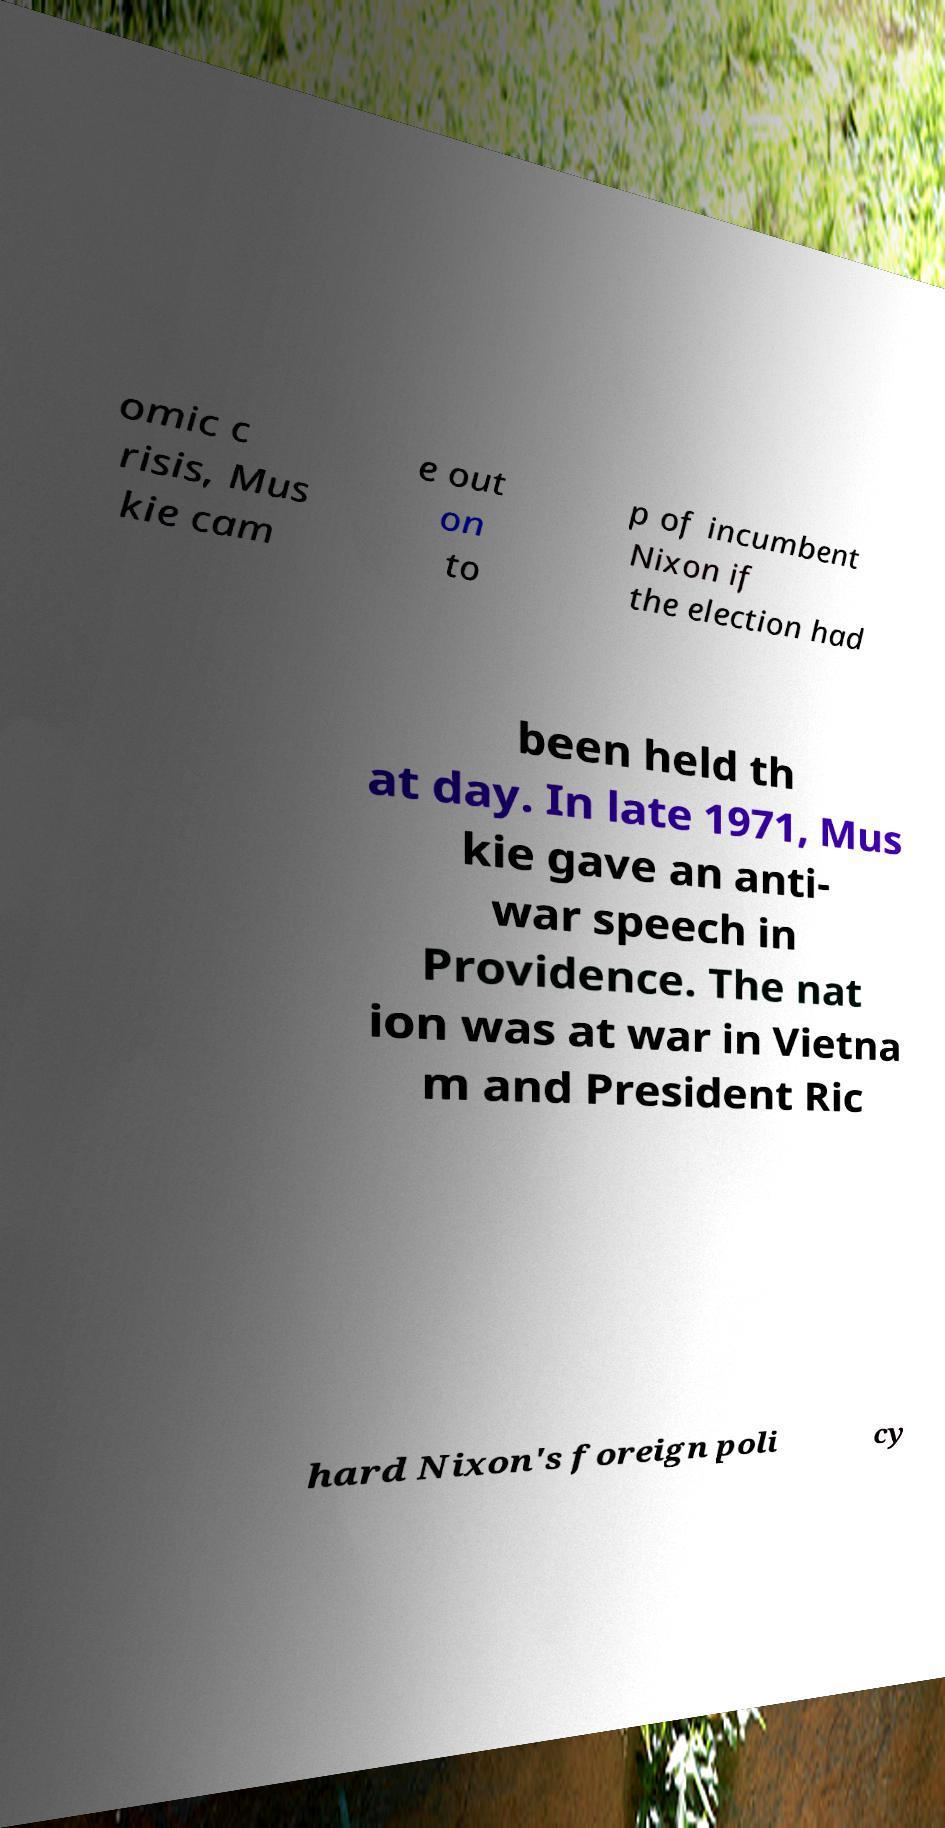Could you extract and type out the text from this image? omic c risis, Mus kie cam e out on to p of incumbent Nixon if the election had been held th at day. In late 1971, Mus kie gave an anti- war speech in Providence. The nat ion was at war in Vietna m and President Ric hard Nixon's foreign poli cy 